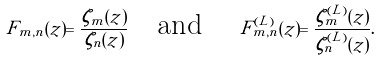<formula> <loc_0><loc_0><loc_500><loc_500>F _ { m , n } ( z ) = \frac { \zeta _ { m } ( z ) } { \zeta _ { n } ( z ) } \quad \text {and } \quad F _ { m , n } ^ { ( L ) } ( z ) = \frac { \zeta _ { m } ^ { ( L ) } ( z ) } { \zeta _ { n } ^ { ( L ) } ( z ) } .</formula> 